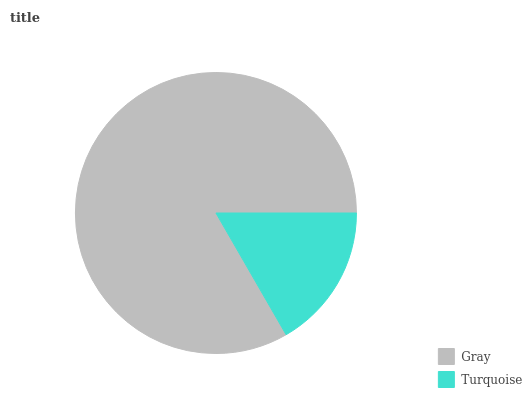Is Turquoise the minimum?
Answer yes or no. Yes. Is Gray the maximum?
Answer yes or no. Yes. Is Turquoise the maximum?
Answer yes or no. No. Is Gray greater than Turquoise?
Answer yes or no. Yes. Is Turquoise less than Gray?
Answer yes or no. Yes. Is Turquoise greater than Gray?
Answer yes or no. No. Is Gray less than Turquoise?
Answer yes or no. No. Is Gray the high median?
Answer yes or no. Yes. Is Turquoise the low median?
Answer yes or no. Yes. Is Turquoise the high median?
Answer yes or no. No. Is Gray the low median?
Answer yes or no. No. 